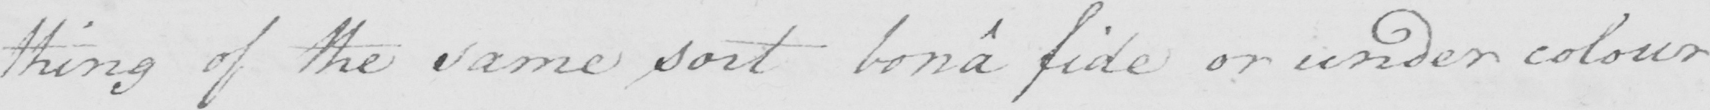What does this handwritten line say? thing of the same sort bona fide or under colour 